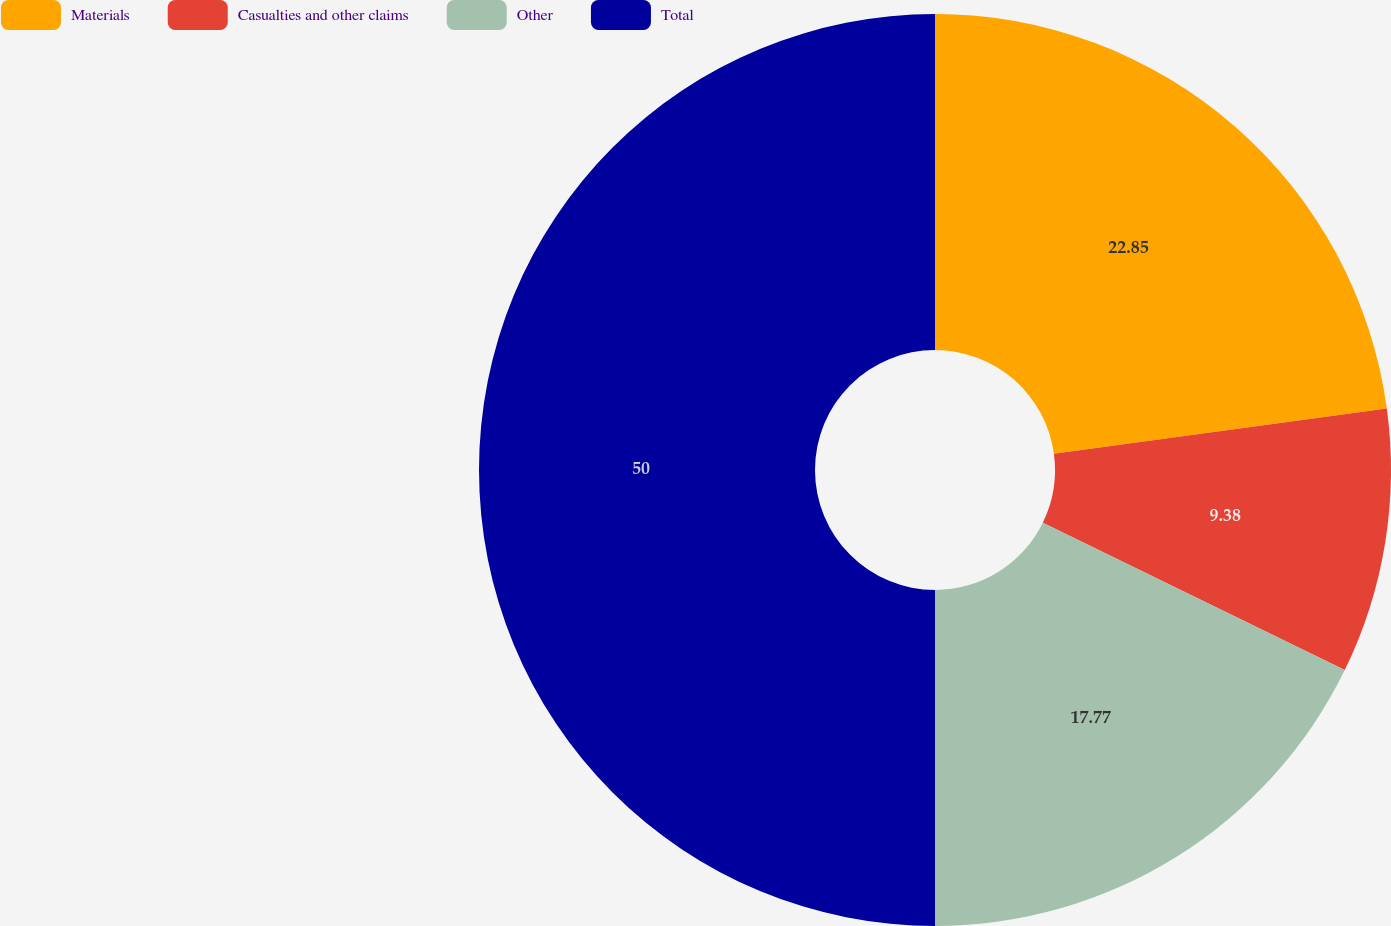Convert chart to OTSL. <chart><loc_0><loc_0><loc_500><loc_500><pie_chart><fcel>Materials<fcel>Casualties and other claims<fcel>Other<fcel>Total<nl><fcel>22.85%<fcel>9.38%<fcel>17.77%<fcel>50.0%<nl></chart> 